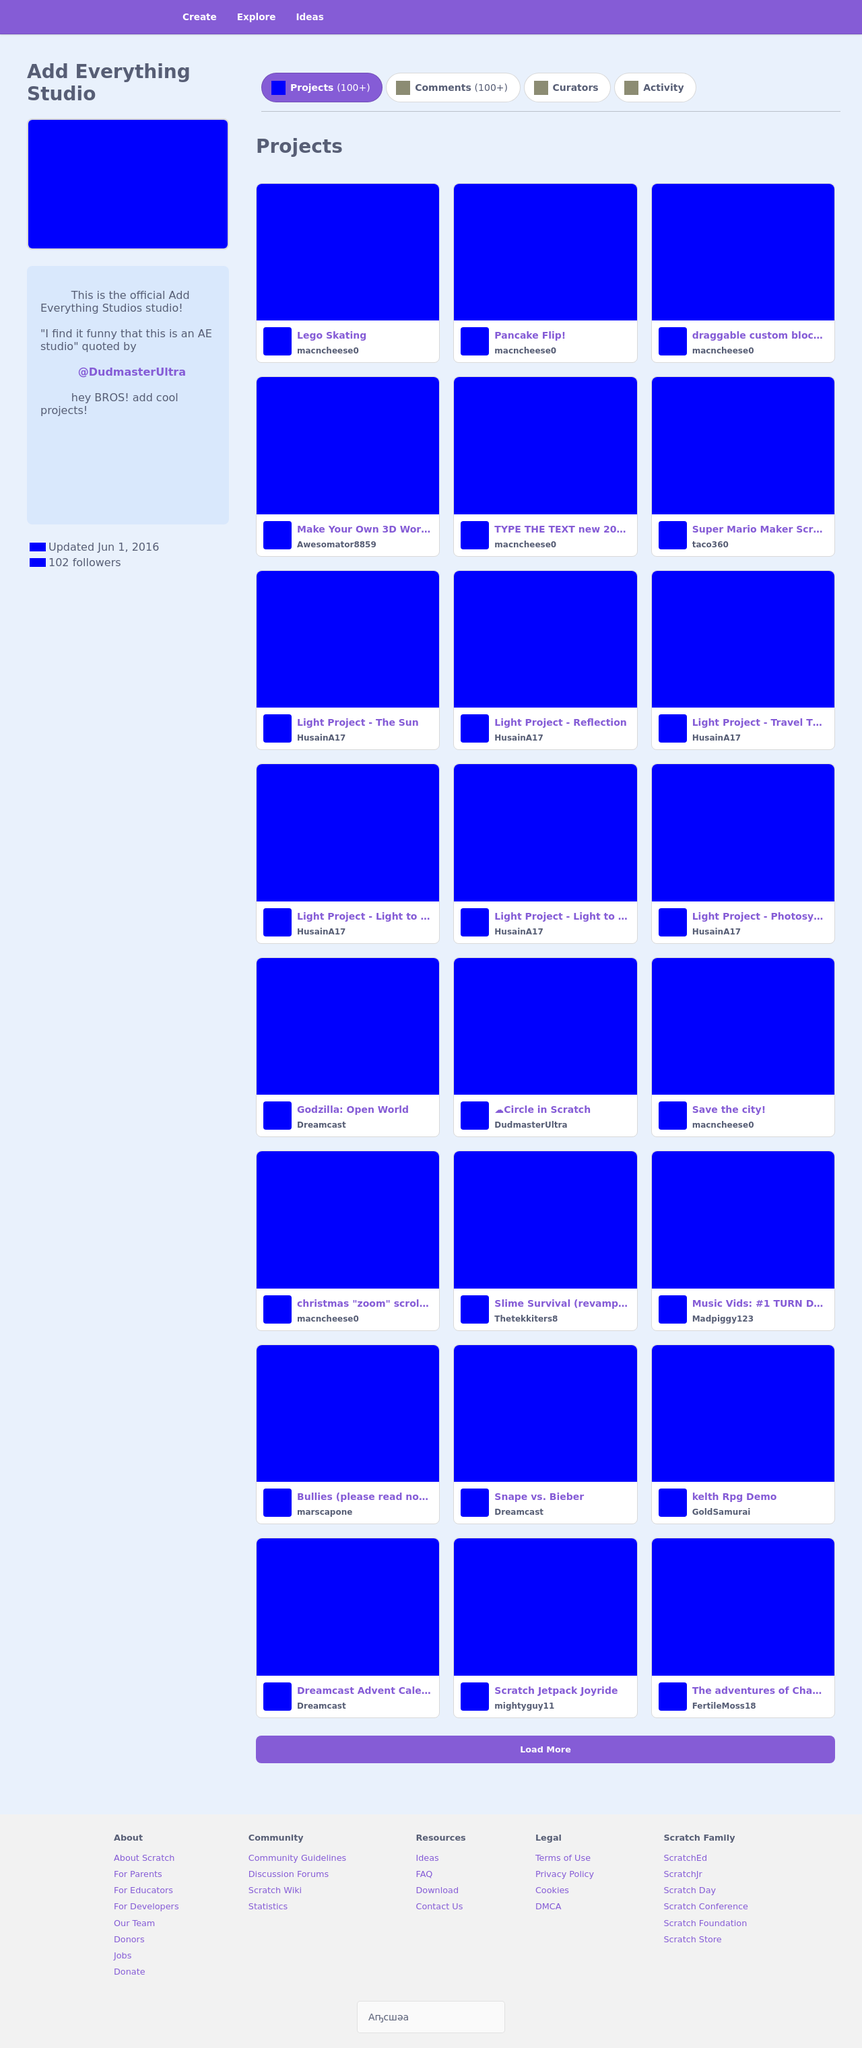Can you describe the theme of the website shown in the image? The website displayed in the image is themed around a collaborative project-hosting platform. It has a very clean and minimal design with a consistent blue color palette. Projects are showcased in individual blue boxes that seem to function as clickable tiles, each containing project titles and potentially clickable links to further project details or interactive elements. 